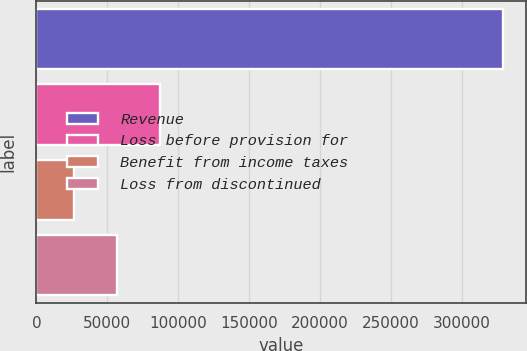<chart> <loc_0><loc_0><loc_500><loc_500><bar_chart><fcel>Revenue<fcel>Loss before provision for<fcel>Benefit from income taxes<fcel>Loss from discontinued<nl><fcel>329031<fcel>87175.8<fcel>26712<fcel>56943.9<nl></chart> 